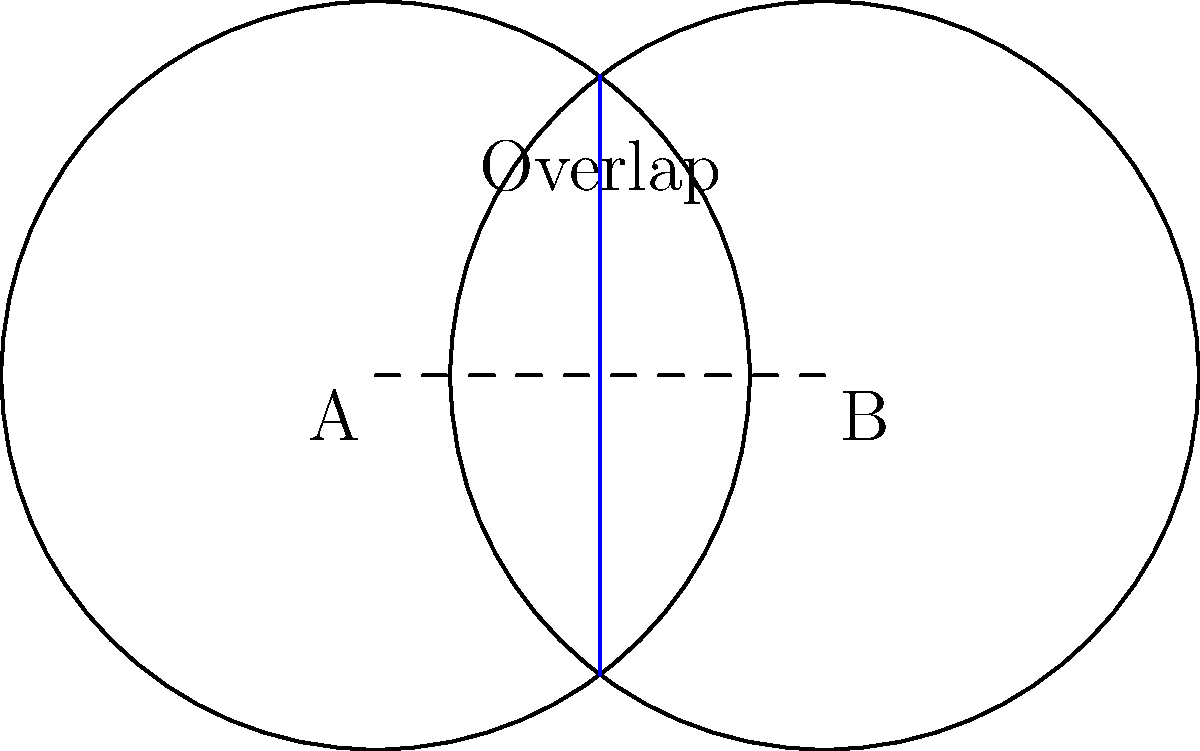Two circular dispensary service zones with radii of 2.5 miles are centered at points A and B, which are 3 miles apart. What is the area of the overlapping region between these two service zones? Round your answer to the nearest hundredth of a square mile. To solve this problem, we'll use the formula for the area of overlap between two circles:

$$A = 2r^2 \arccos(\frac{d}{2r}) - d\sqrt{r^2 - \frac{d^2}{4}}$$

Where:
$A$ is the area of overlap
$r$ is the radius of each circle
$d$ is the distance between the centers

Step 1: Identify the given values
$r = 2.5$ miles
$d = 3$ miles

Step 2: Substitute these values into the formula
$$A = 2(2.5^2) \arccos(\frac{3}{2(2.5)}) - 3\sqrt{2.5^2 - \frac{3^2}{4}}$$

Step 3: Simplify the expression inside the arccos function
$$A = 2(6.25) \arccos(\frac{3}{5}) - 3\sqrt{6.25 - 2.25}$$

Step 4: Calculate the arccos value (in radians)
$\arccos(\frac{3}{5}) \approx 0.9273$

Step 5: Simplify the square root
$$A = 12.5(0.9273) - 3\sqrt{4}$$
$$A = 11.59125 - 3(2)$$
$$A = 11.59125 - 6$$
$$A = 5.59125$$

Step 6: Round to the nearest hundredth
$A \approx 5.59$ square miles
Answer: 5.59 square miles 